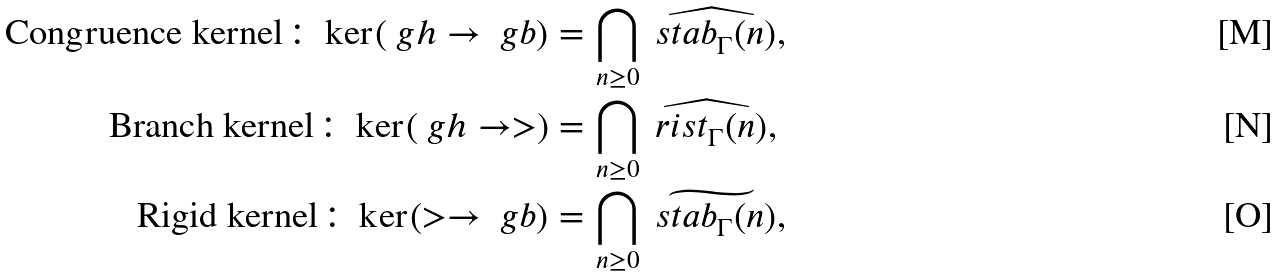<formula> <loc_0><loc_0><loc_500><loc_500>\text {Congruence kernel} \colon \ker ( \ g h \to \ g b ) & = \bigcap _ { n \geq 0 } \widehat { \ s t a b _ { \Gamma } ( n ) } , \\ \text {Branch kernel} \colon \ker ( \ g h \to > ) & = \bigcap _ { n \geq 0 } \widehat { \ r i s t _ { \Gamma } ( n ) } , \\ \text {Rigid kernel} \colon \ker ( > \to \ g b ) & = \bigcap _ { n \geq 0 } \widetilde { \ s t a b _ { \Gamma } ( n ) } ,</formula> 